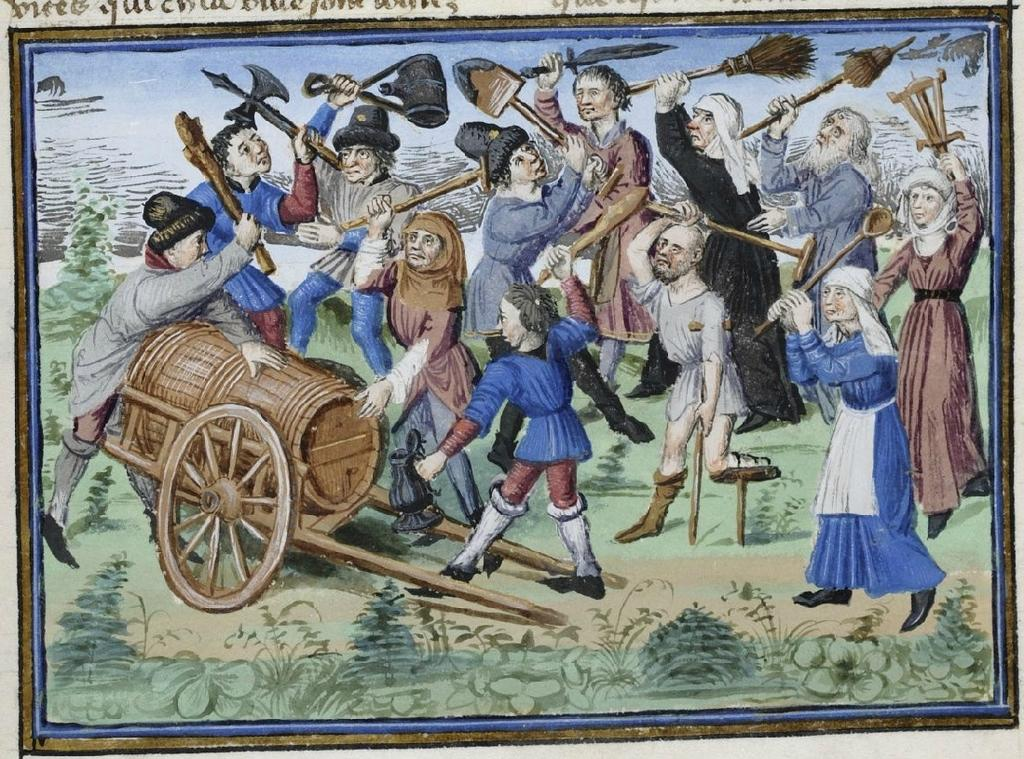What is the main object in the image? There is a drawing poster in the image. What can be seen in the front of the image? There are many men and women in the front of the image. What are the men and women doing in the image? The men and women are standing and holding broomsticks in their hands. What is located on the left side of the image? There is a chariot on the left side of the image. What type of stem is visible on the drawing poster in the image? There is no stem visible on the drawing poster in the image. How does the behavior of the men and women change throughout the image? The provided facts do not mention any changes in the behavior of the men and women throughout the image. 